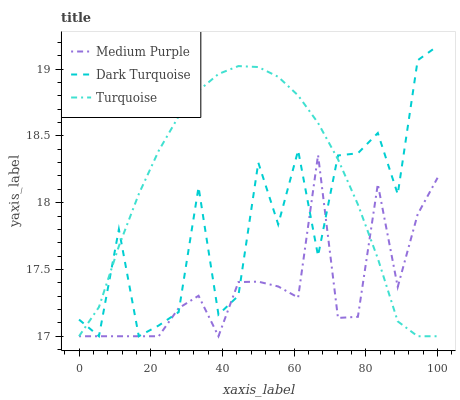Does Medium Purple have the minimum area under the curve?
Answer yes or no. Yes. Does Dark Turquoise have the minimum area under the curve?
Answer yes or no. No. Does Dark Turquoise have the maximum area under the curve?
Answer yes or no. No. Is Dark Turquoise the roughest?
Answer yes or no. Yes. Is Dark Turquoise the smoothest?
Answer yes or no. No. Is Turquoise the roughest?
Answer yes or no. No. Does Turquoise have the highest value?
Answer yes or no. No. 